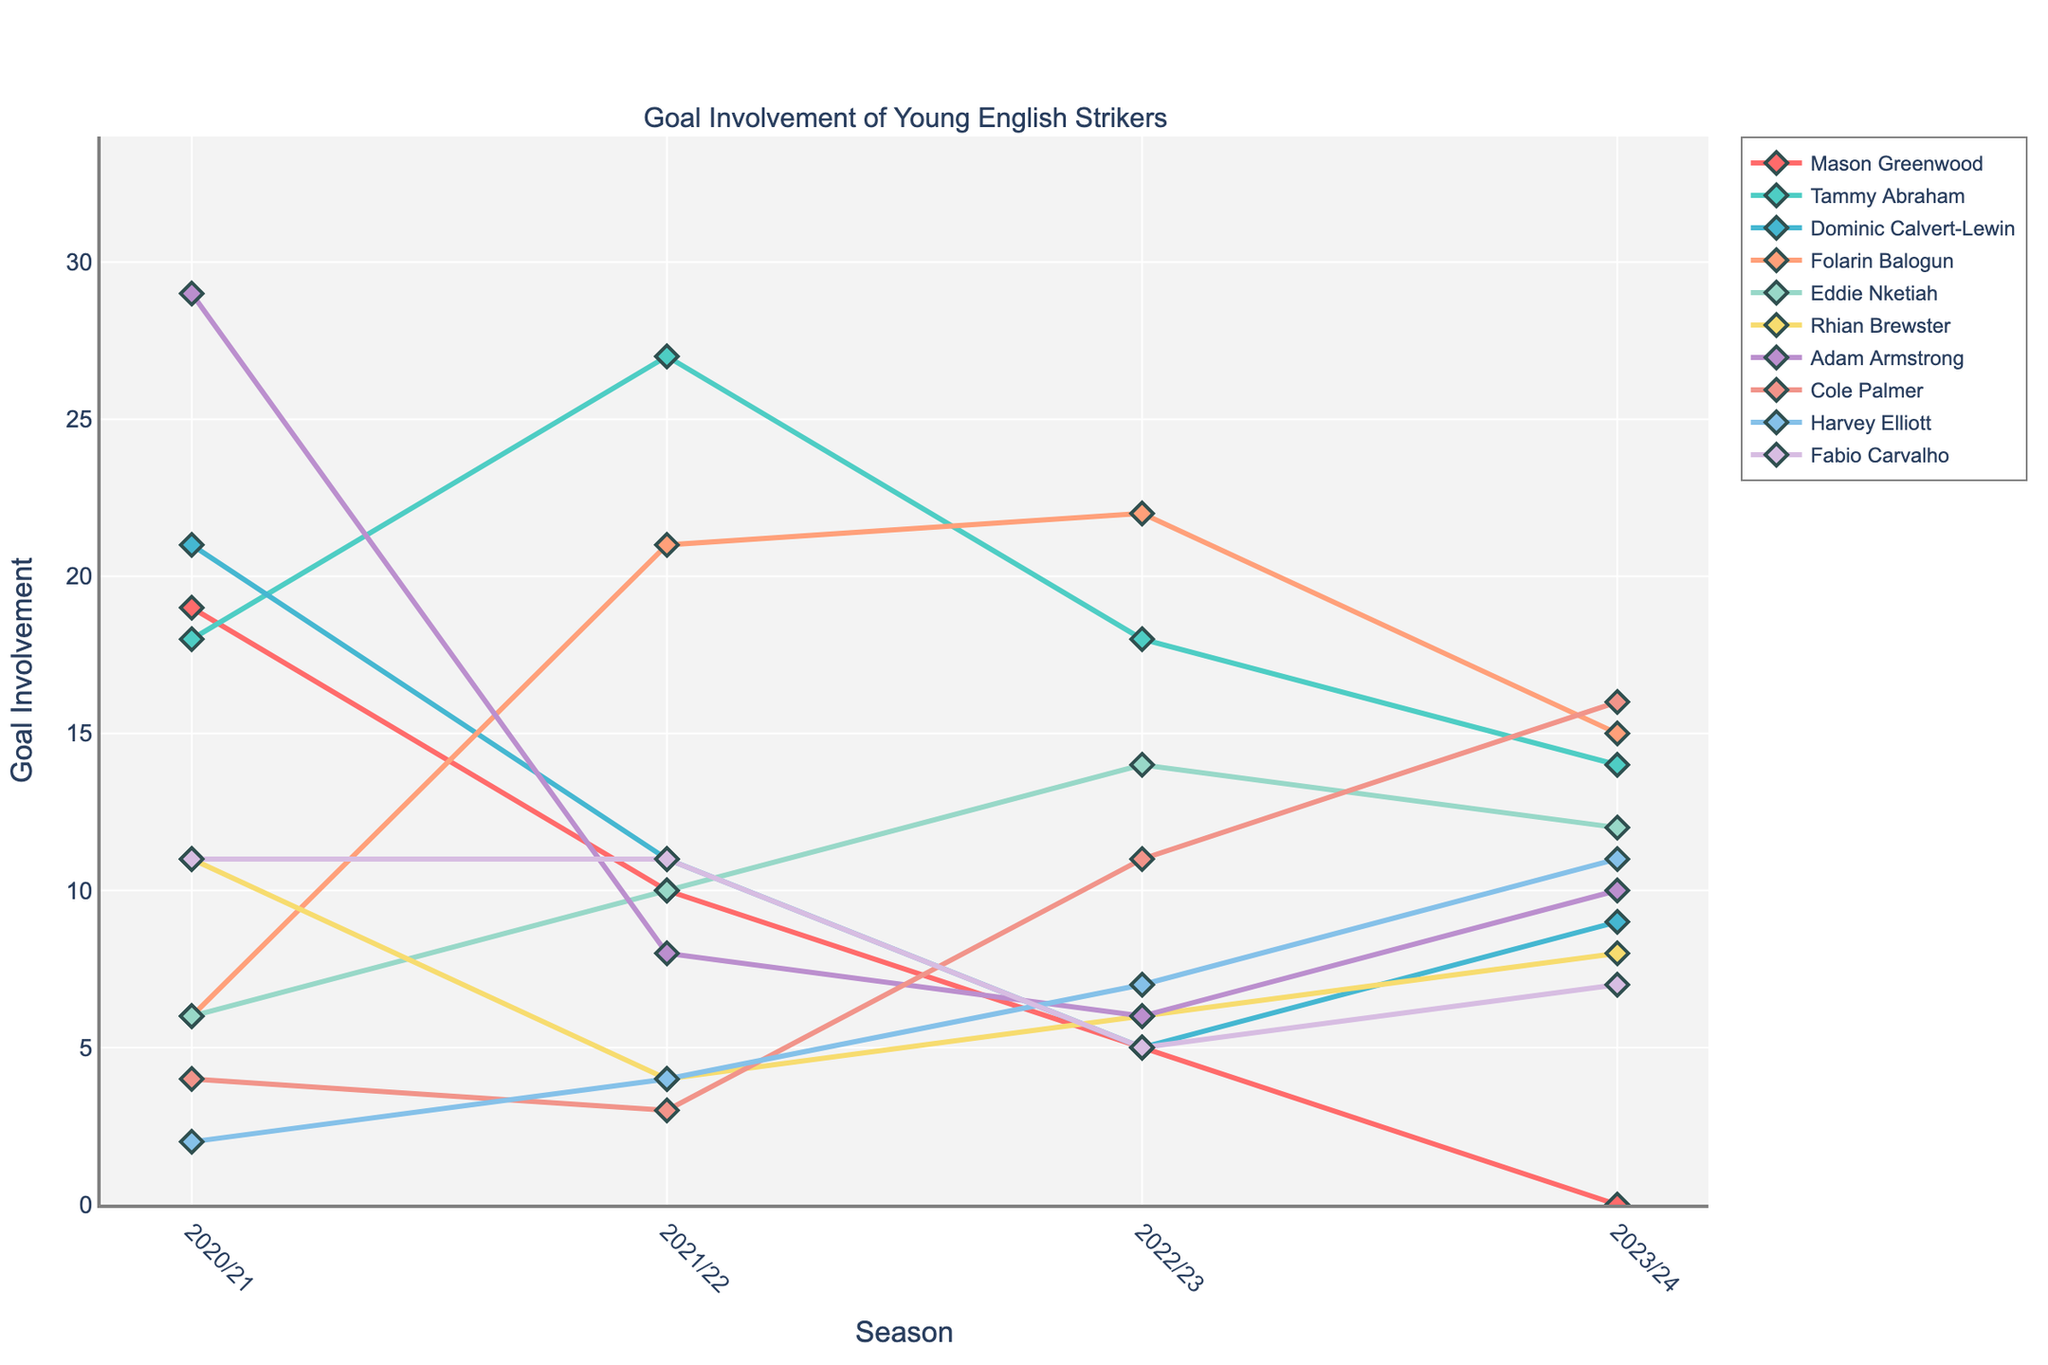Which player had the highest goal involvement in the 2020/21 season? Looking at the lines and markers representing the players in the 2020/21 season, Adam Armstrong had the highest peak at 29.
Answer: Adam Armstrong Which player showed the most significant improvement from the 2020/21 to 2021/22 season? By comparing the height of the lines from 2020/21 to 2021/22, Folarin Balogun’s goal involvement increased from 6 to 21, which is the largest improvement.
Answer: Folarin Balogun Who had the most stable goal involvement across the four seasons? By examining the lines, Mason Greenwood’s line remains relatively flat compared to others, although it decreases, showing less variance across the four seasons.
Answer: Mason Greenwood Which two players had an equal goal involvement in the 2020/21 season, and what was it? By matching the heights of the markers in the 2020/21 season, Folarin Balogun and Eddie Nketiah both had a goal involvement of 6.
Answer: Folarin Balogun and Eddie Nketiah, 6 How did Tammy Abraham's goal involvement change from 2021/22 to 2023/24? Tracking Tammy Abraham's line, the goal involvement decreased from 27 in 2021/22 to 14 in 2023/24.
Answer: Decreased Which player had the lowest goal involvement in the 2022/23 season? Observing the heights of the markers in the 2022/23 season, Mason Greenwood had the lowest at 5.
Answer: Mason Greenwood By how much did Dominic Calvert-Lewin's goal involvement increase from 2022/23 to 2023/24? Comparing the markers for Dominic Calvert-Lewin between the 2022/23 and 2023/24 seasons, the values go from 5 to 9, an increase of 4.
Answer: 4 Which player had the biggest drop in goal involvement from one season to another? By looking at the steepest decline in the lines, Mason Greenwood’s involvement went from 19 in 2020/21 to 10 in 2021/22, a drop of 9.
Answer: Mason Greenwood How does the goal involvement of Cole Palmer in the 2022/23 season compare to that in 2023/24? Observing Cole Palmer’s line, his goal involvement increased from 11 in 2022/23 to 16 in 2023/24.
Answer: Increased 